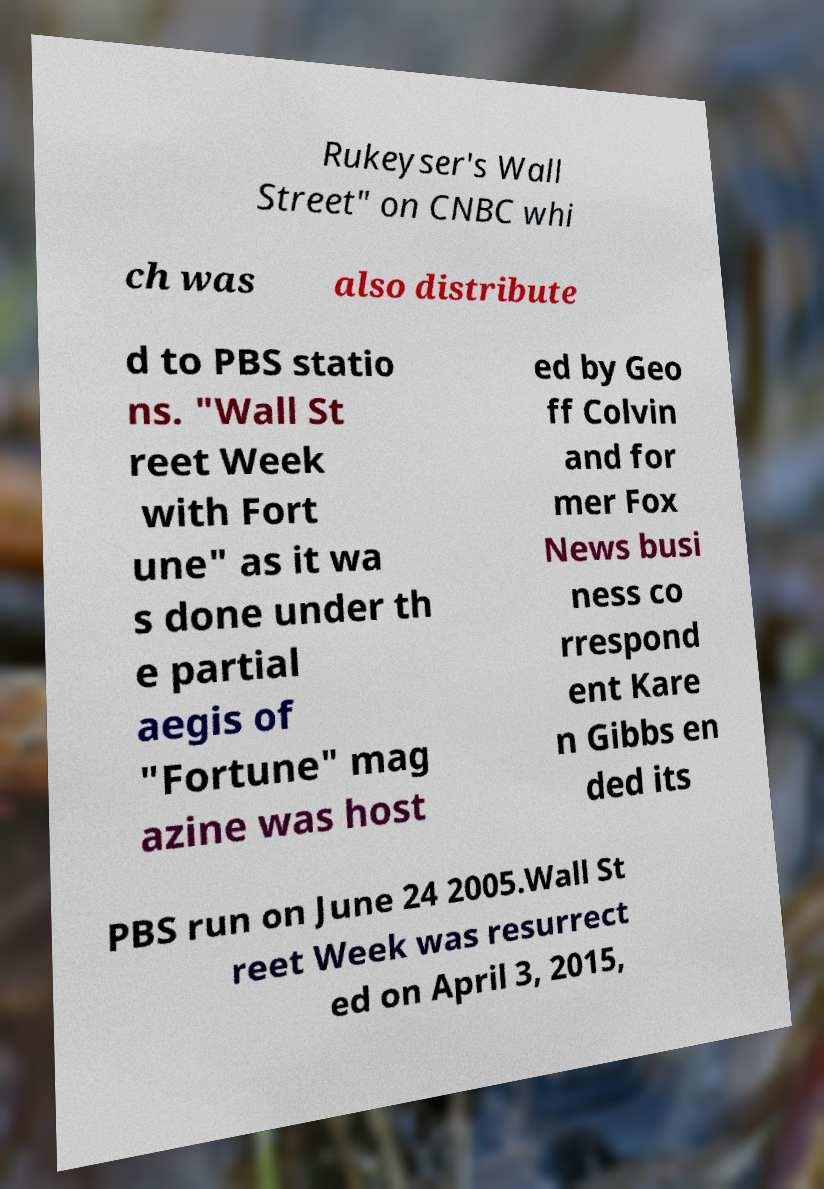For documentation purposes, I need the text within this image transcribed. Could you provide that? Rukeyser's Wall Street" on CNBC whi ch was also distribute d to PBS statio ns. "Wall St reet Week with Fort une" as it wa s done under th e partial aegis of "Fortune" mag azine was host ed by Geo ff Colvin and for mer Fox News busi ness co rrespond ent Kare n Gibbs en ded its PBS run on June 24 2005.Wall St reet Week was resurrect ed on April 3, 2015, 